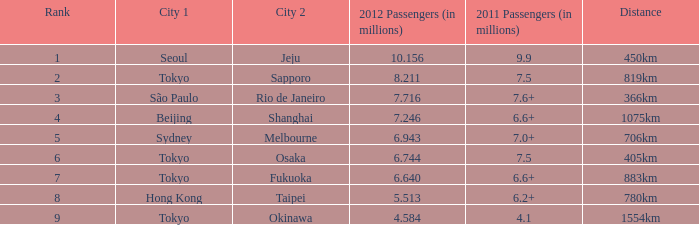What the is the first city listed on the route that had 6.6+ passengers in 2011 and a distance of 1075km? Beijing. 